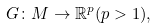<formula> <loc_0><loc_0><loc_500><loc_500>G \colon M \to \mathbb { R } ^ { p } ( p > 1 ) ,</formula> 